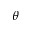Convert formula to latex. <formula><loc_0><loc_0><loc_500><loc_500>\theta</formula> 